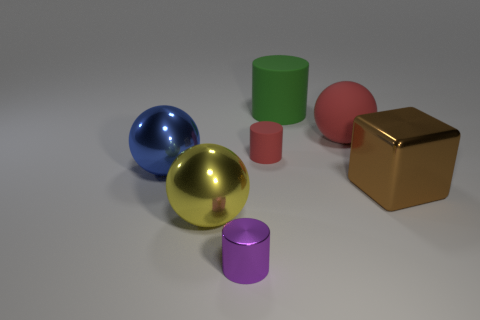What can you tell me about the lighting in this scene? The scene is lit in a way that suggests a single, diffuse light source from above, casting soft shadows directly underneath the objects. Such lighting minimizes harsh shadows and highlights, creating a neutral and balanced visual environment. Does this lighting affect how the colors of the objects are perceived? Absolutely, diffuse lighting tends to bring out the true colors of objects by reducing glare and preserving the subtlety of shades. It allows for more accurate perception of color and texture without oversaturation or distortion. 